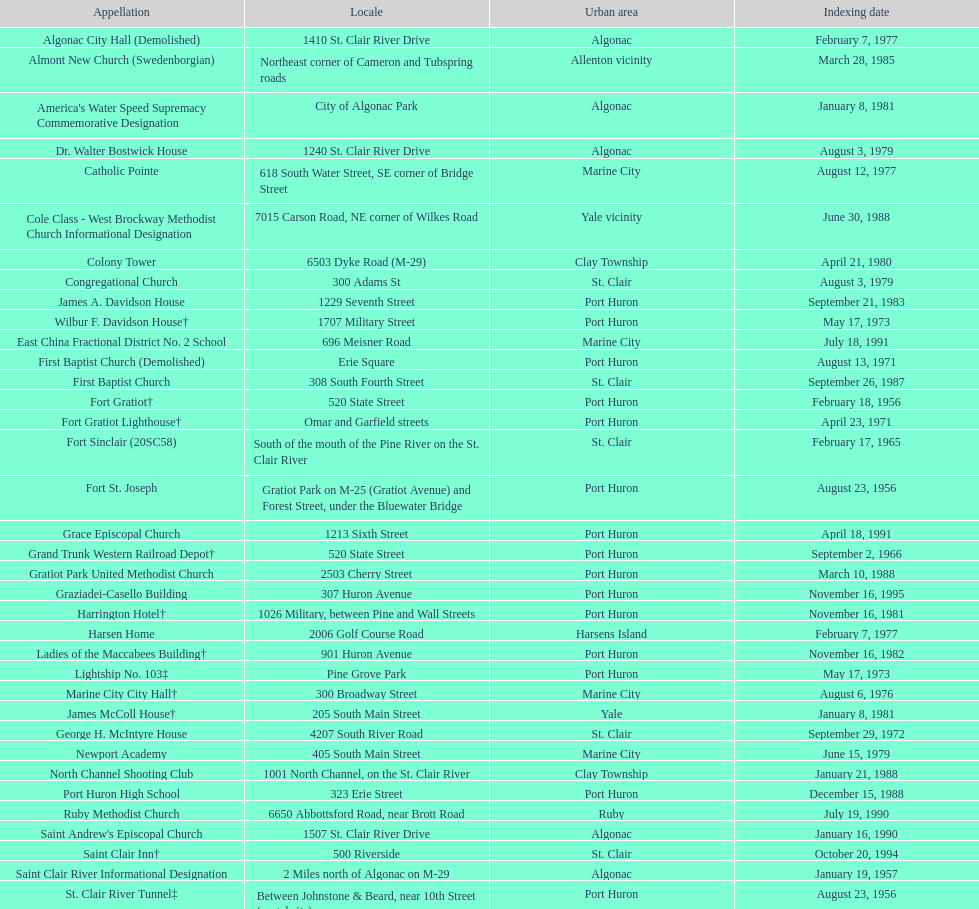How many names do not have images next to them? 41. 